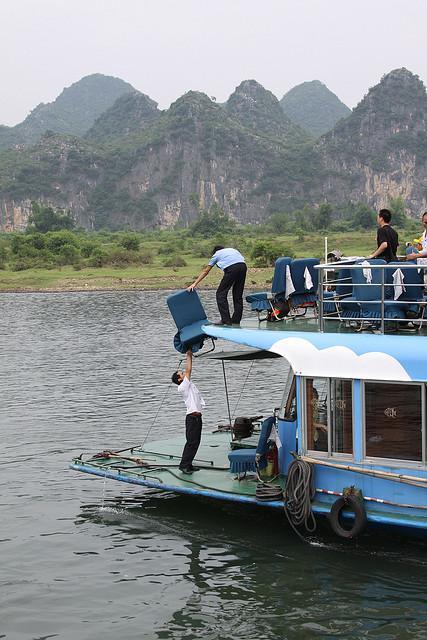How many people on this boat are visible?
Give a very brief answer. 4. How many people are there?
Give a very brief answer. 2. How many baby elephants are there?
Give a very brief answer. 0. 